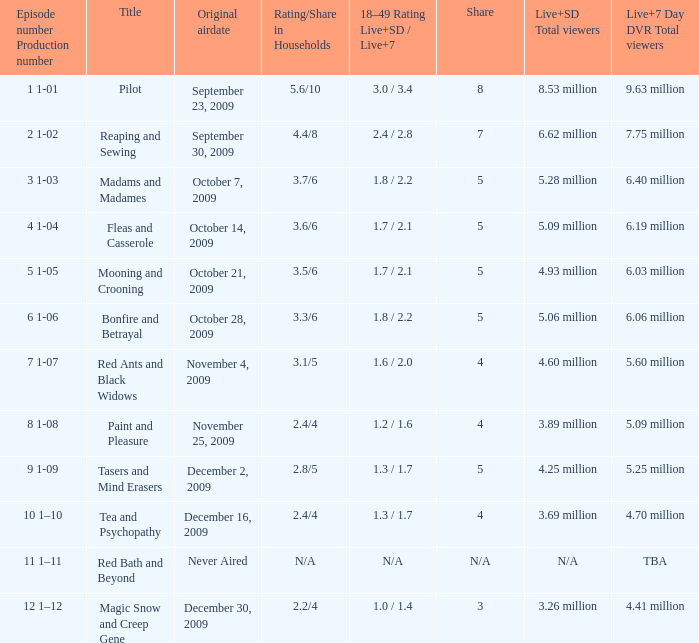What are the total viewers (live and sd together) for the episode that had a share of 8? 9.63 million. 